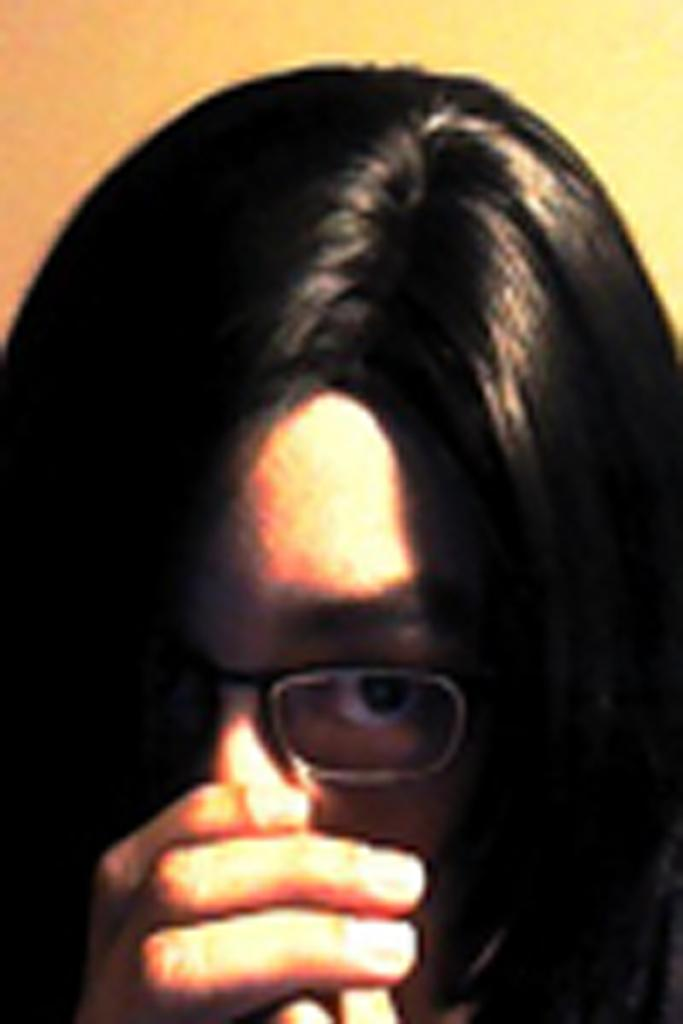Who is the main subject in the image? There is a lady in the image. Can you describe the background of the image? The background of the image is blurred. What type of pan can be seen in the image? There is no pan present in the image. What kind of cracker is the lady holding in the image? There is no cracker present in the image. 